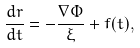Convert formula to latex. <formula><loc_0><loc_0><loc_500><loc_500>\frac { d { r } } { d t } = - \frac { \nabla \Phi } { \xi } + { f } ( t ) ,</formula> 